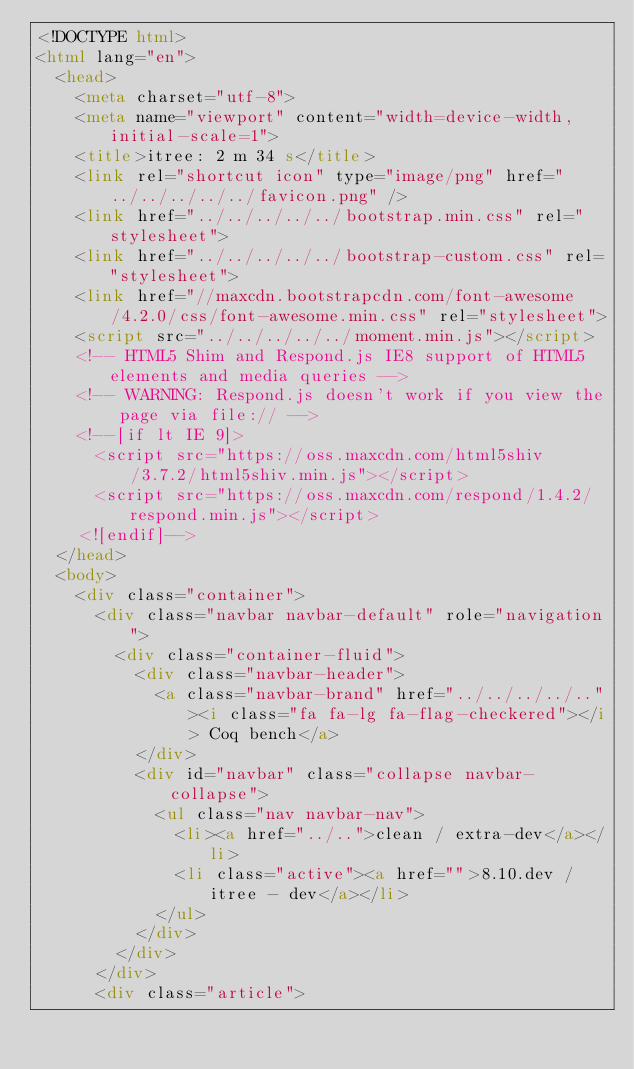<code> <loc_0><loc_0><loc_500><loc_500><_HTML_><!DOCTYPE html>
<html lang="en">
  <head>
    <meta charset="utf-8">
    <meta name="viewport" content="width=device-width, initial-scale=1">
    <title>itree: 2 m 34 s</title>
    <link rel="shortcut icon" type="image/png" href="../../../../../favicon.png" />
    <link href="../../../../../bootstrap.min.css" rel="stylesheet">
    <link href="../../../../../bootstrap-custom.css" rel="stylesheet">
    <link href="//maxcdn.bootstrapcdn.com/font-awesome/4.2.0/css/font-awesome.min.css" rel="stylesheet">
    <script src="../../../../../moment.min.js"></script>
    <!-- HTML5 Shim and Respond.js IE8 support of HTML5 elements and media queries -->
    <!-- WARNING: Respond.js doesn't work if you view the page via file:// -->
    <!--[if lt IE 9]>
      <script src="https://oss.maxcdn.com/html5shiv/3.7.2/html5shiv.min.js"></script>
      <script src="https://oss.maxcdn.com/respond/1.4.2/respond.min.js"></script>
    <![endif]-->
  </head>
  <body>
    <div class="container">
      <div class="navbar navbar-default" role="navigation">
        <div class="container-fluid">
          <div class="navbar-header">
            <a class="navbar-brand" href="../../../../.."><i class="fa fa-lg fa-flag-checkered"></i> Coq bench</a>
          </div>
          <div id="navbar" class="collapse navbar-collapse">
            <ul class="nav navbar-nav">
              <li><a href="../..">clean / extra-dev</a></li>
              <li class="active"><a href="">8.10.dev / itree - dev</a></li>
            </ul>
          </div>
        </div>
      </div>
      <div class="article"></code> 